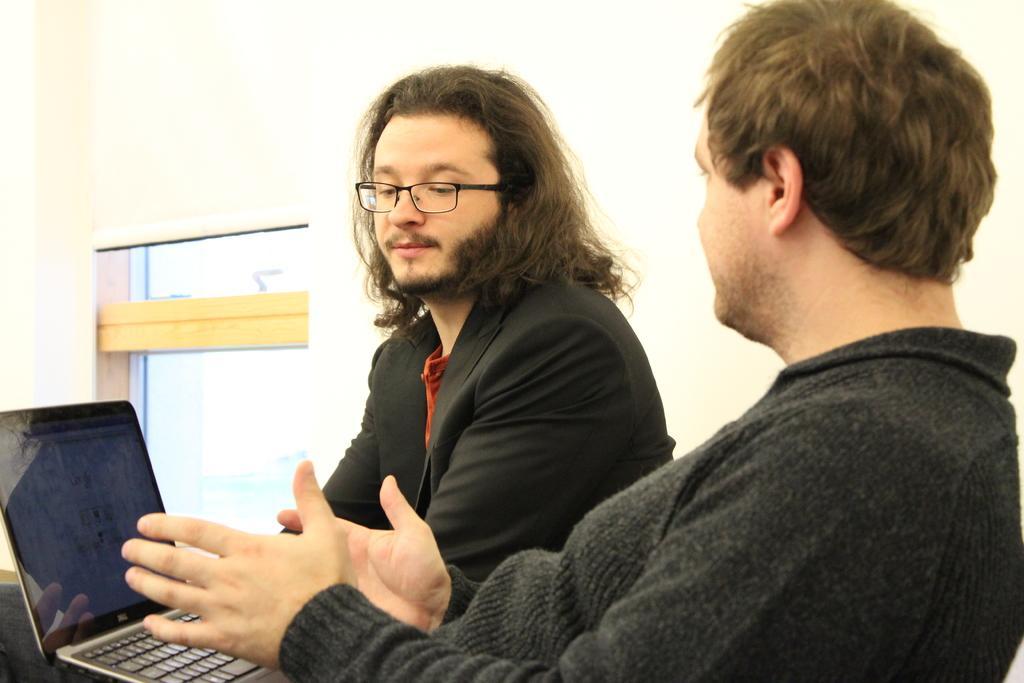Describe this image in one or two sentences. In the center of the image we can see two persons are sitting and they are in different costumes. Among them, we can see one person is wearing glasses. In front of them, there is a laptop on some object. In the background, we can see a few other objects. 